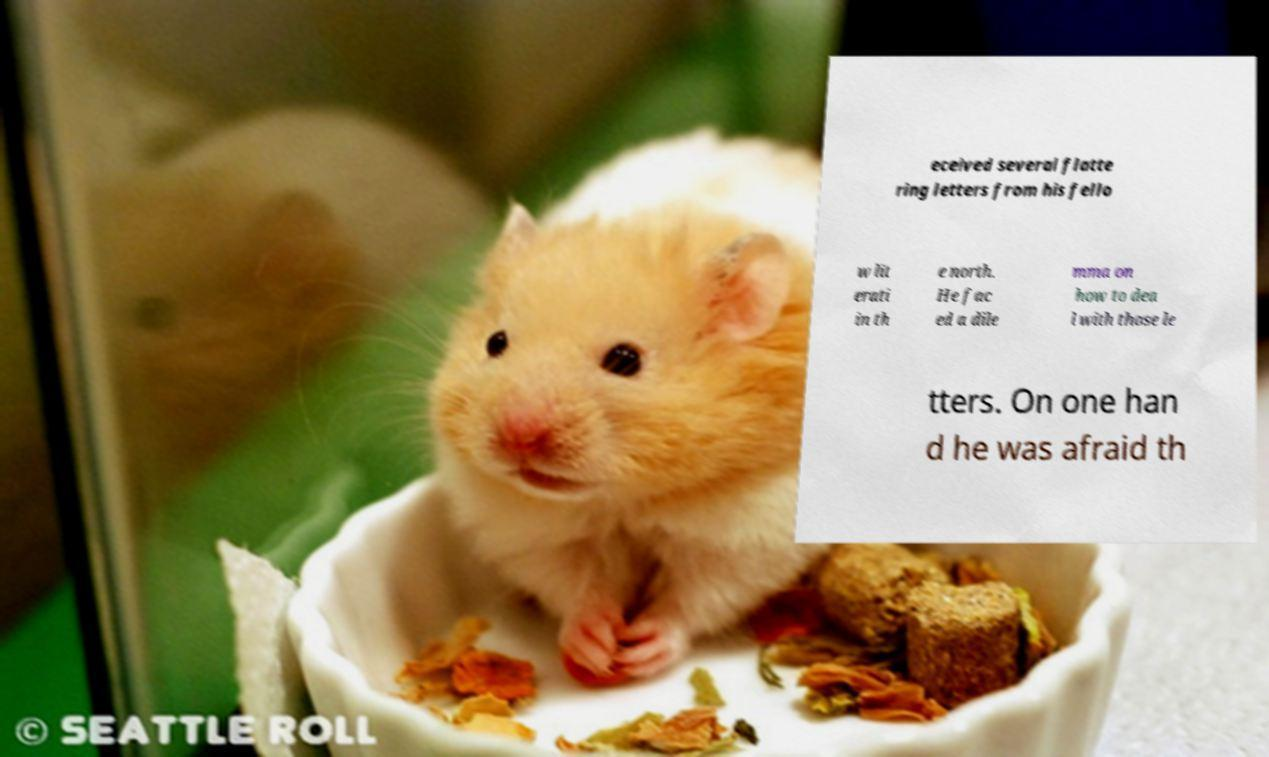What messages or text are displayed in this image? I need them in a readable, typed format. eceived several flatte ring letters from his fello w lit erati in th e north. He fac ed a dile mma on how to dea l with those le tters. On one han d he was afraid th 